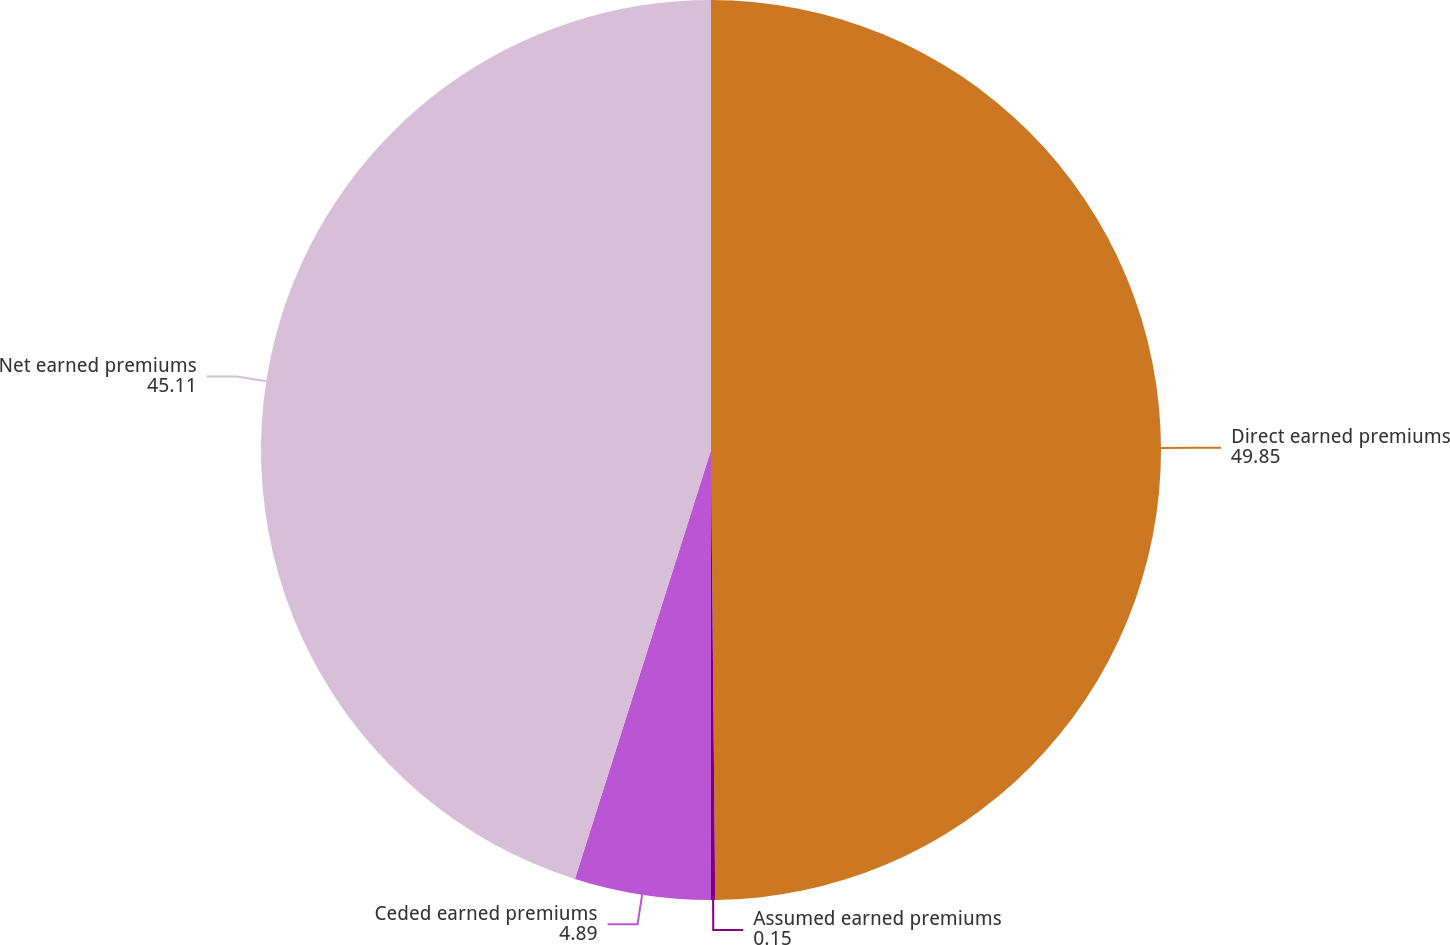Convert chart. <chart><loc_0><loc_0><loc_500><loc_500><pie_chart><fcel>Direct earned premiums<fcel>Assumed earned premiums<fcel>Ceded earned premiums<fcel>Net earned premiums<nl><fcel>49.85%<fcel>0.15%<fcel>4.89%<fcel>45.11%<nl></chart> 